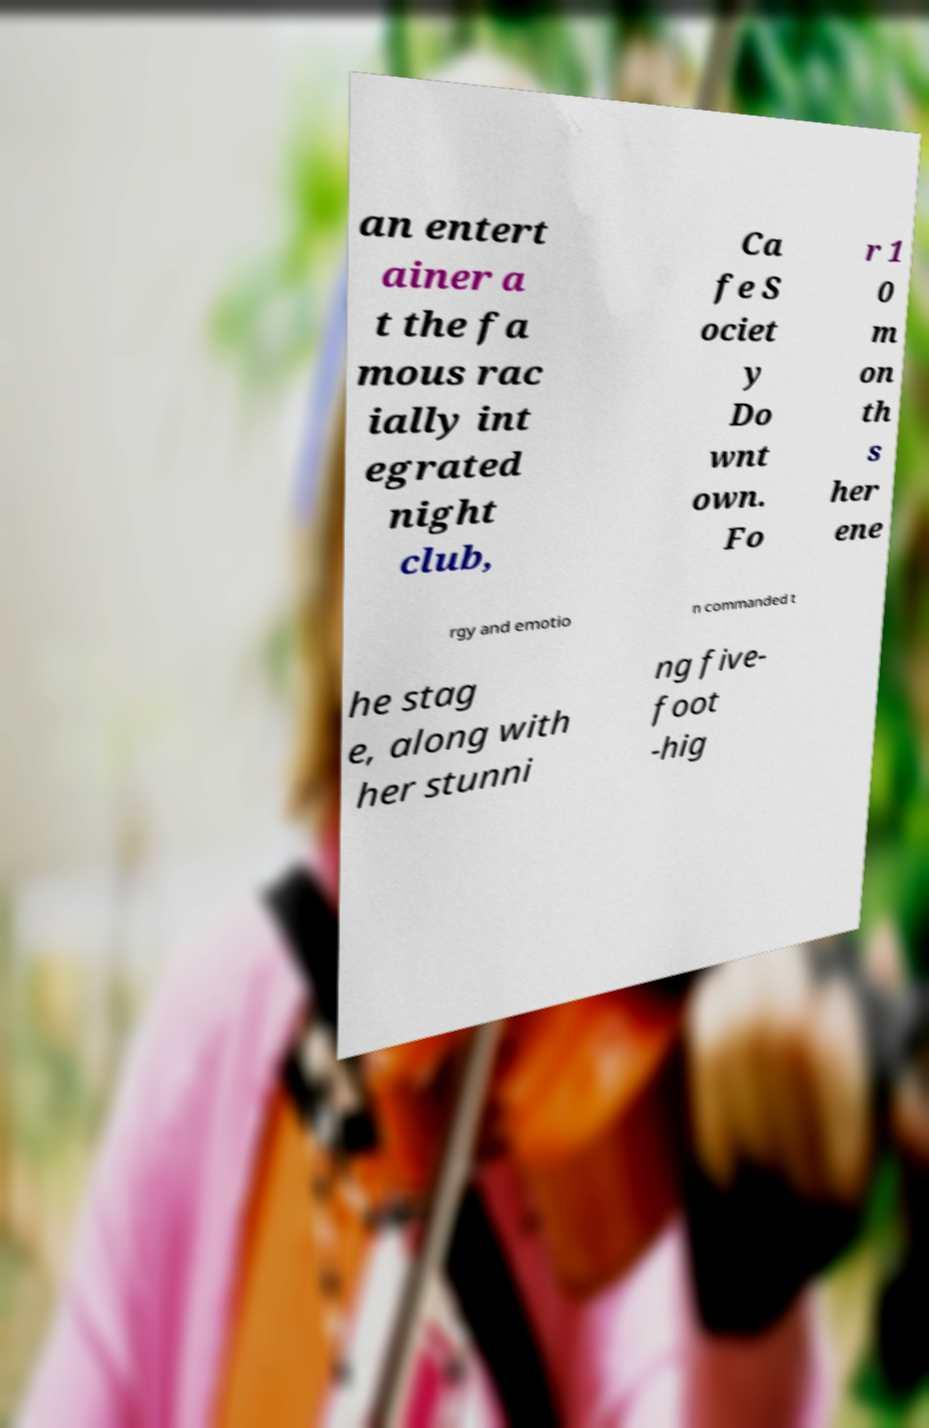Can you read and provide the text displayed in the image?This photo seems to have some interesting text. Can you extract and type it out for me? an entert ainer a t the fa mous rac ially int egrated night club, Ca fe S ociet y Do wnt own. Fo r 1 0 m on th s her ene rgy and emotio n commanded t he stag e, along with her stunni ng five- foot -hig 